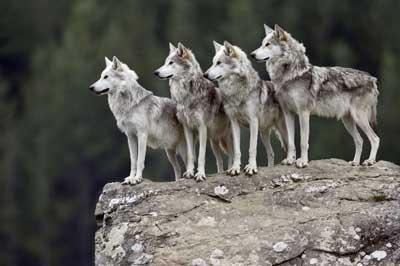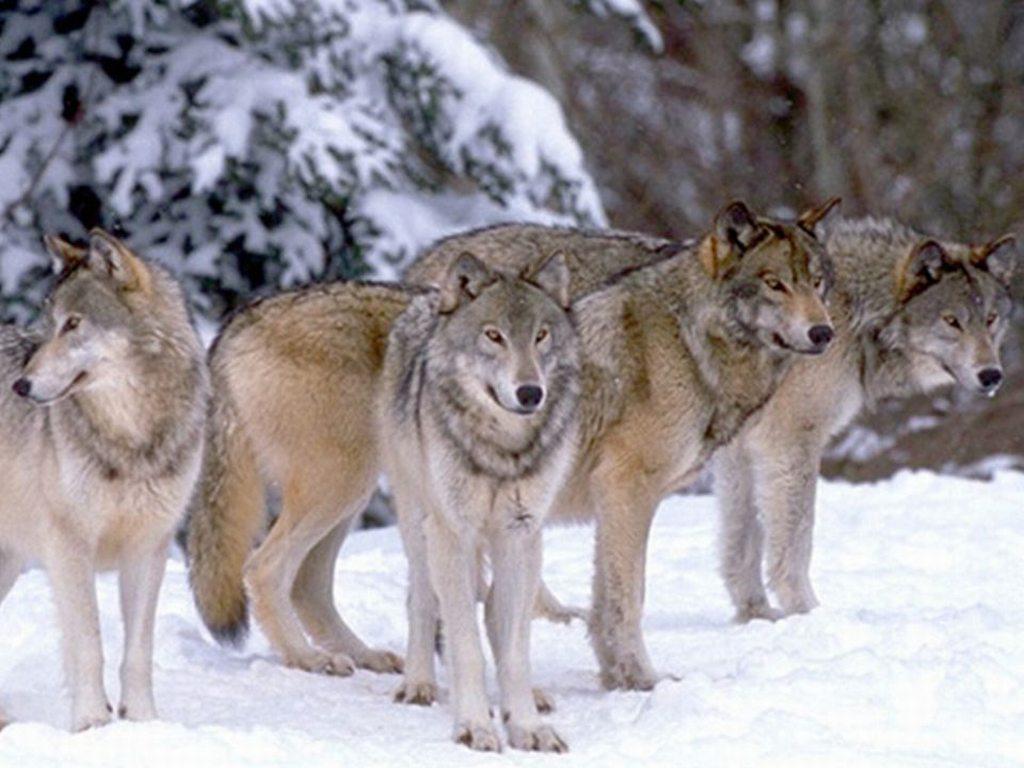The first image is the image on the left, the second image is the image on the right. For the images displayed, is the sentence "There is at least one image where there are five or more wolves." factually correct? Answer yes or no. No. The first image is the image on the left, the second image is the image on the right. Given the left and right images, does the statement "There is a black wolf on the left side of the image." hold true? Answer yes or no. No. 